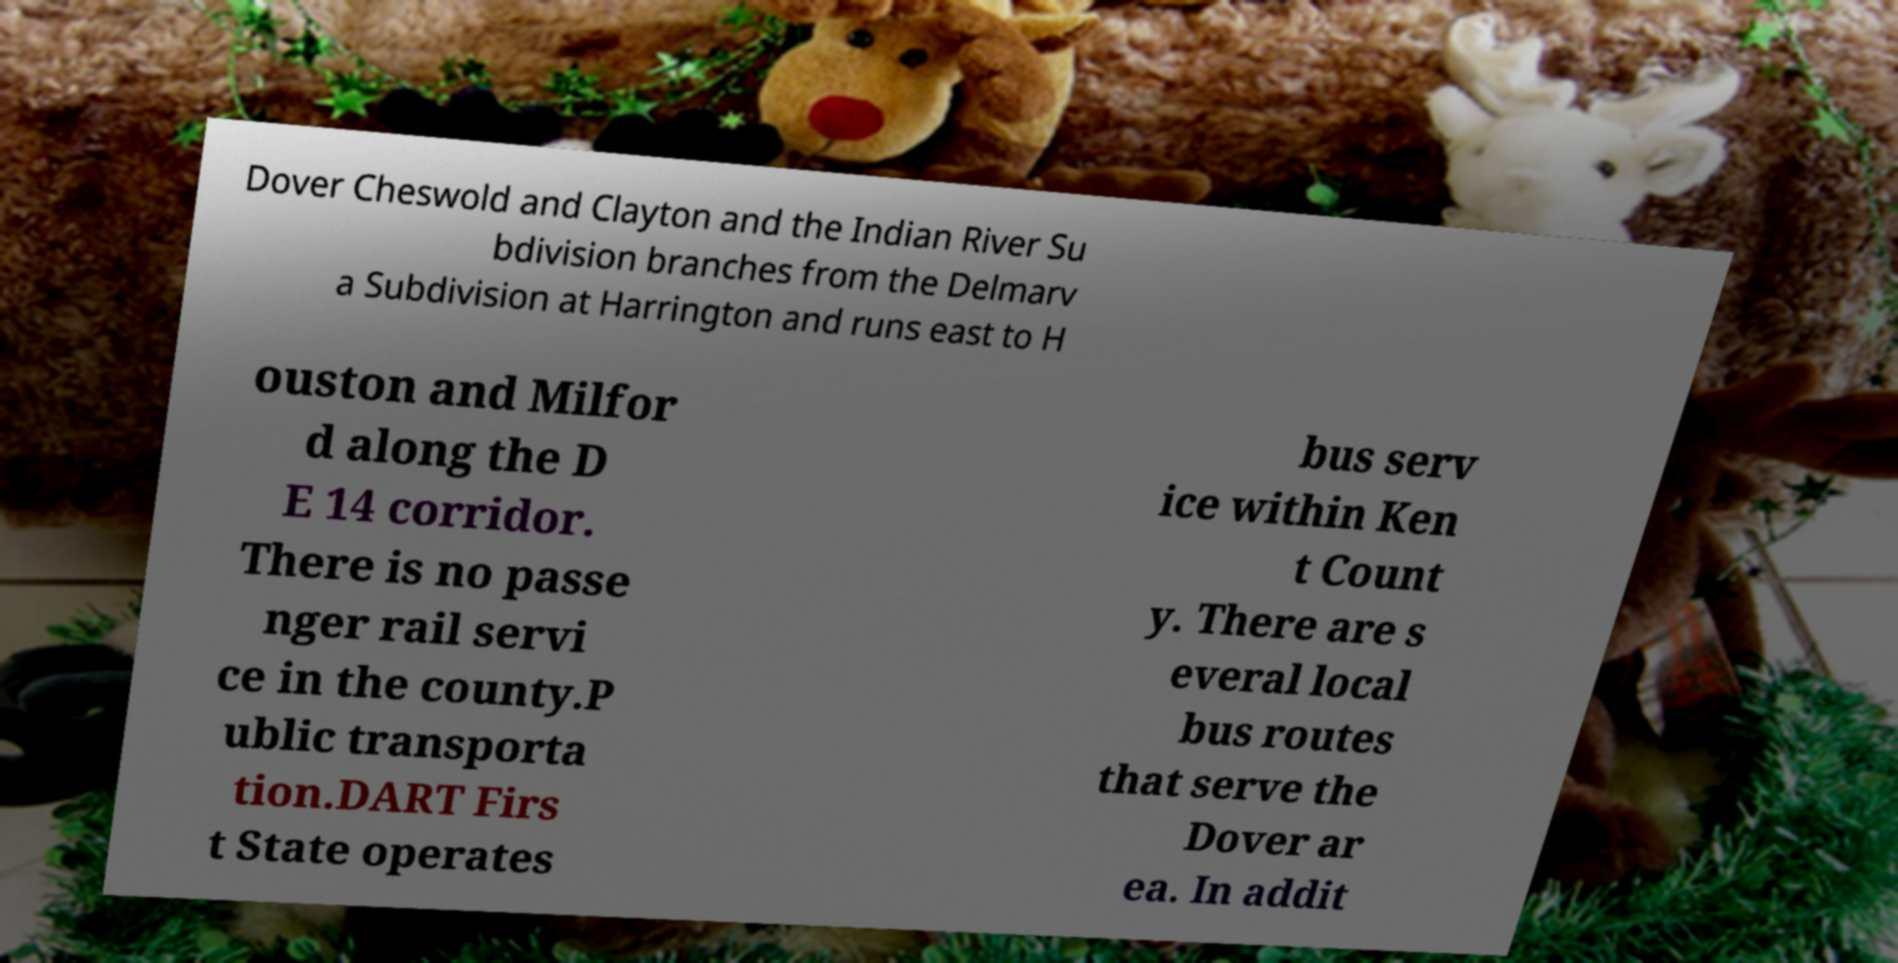Could you extract and type out the text from this image? Dover Cheswold and Clayton and the Indian River Su bdivision branches from the Delmarv a Subdivision at Harrington and runs east to H ouston and Milfor d along the D E 14 corridor. There is no passe nger rail servi ce in the county.P ublic transporta tion.DART Firs t State operates bus serv ice within Ken t Count y. There are s everal local bus routes that serve the Dover ar ea. In addit 